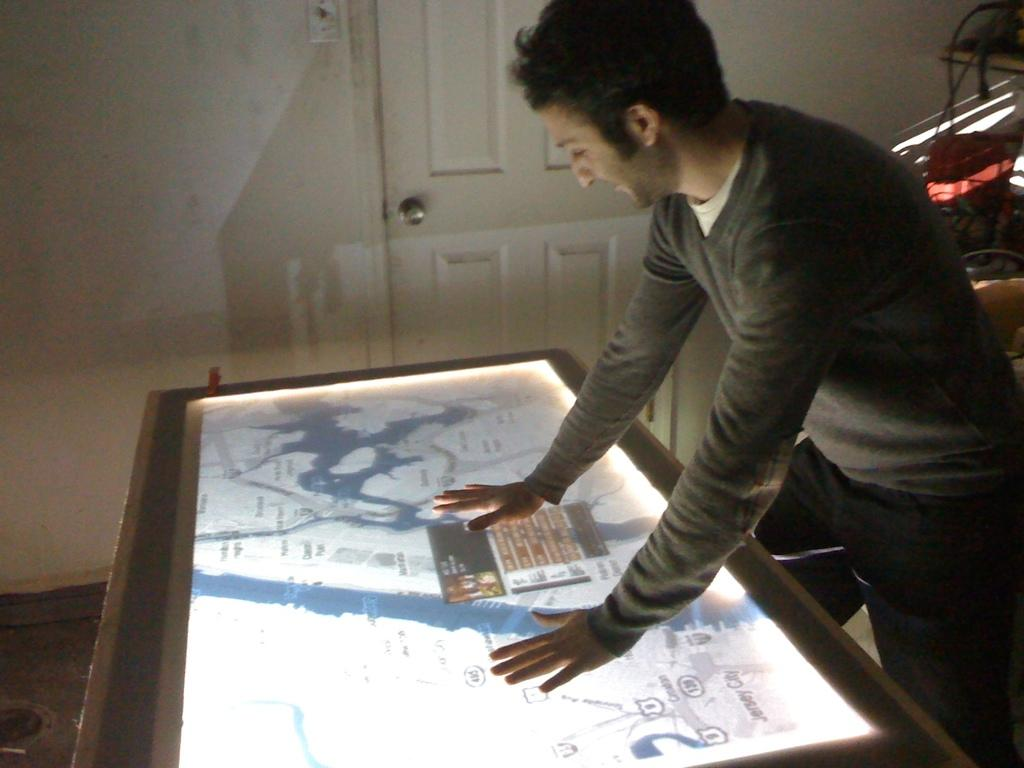What is the person in the image doing? The person is standing in front of a screen. Can you describe any other objects or features in the image? There is a door in the image. Where is the door located? The door is on a wall. What type of knife is being used to cut the crib in the image? There is no knife or crib present in the image. 